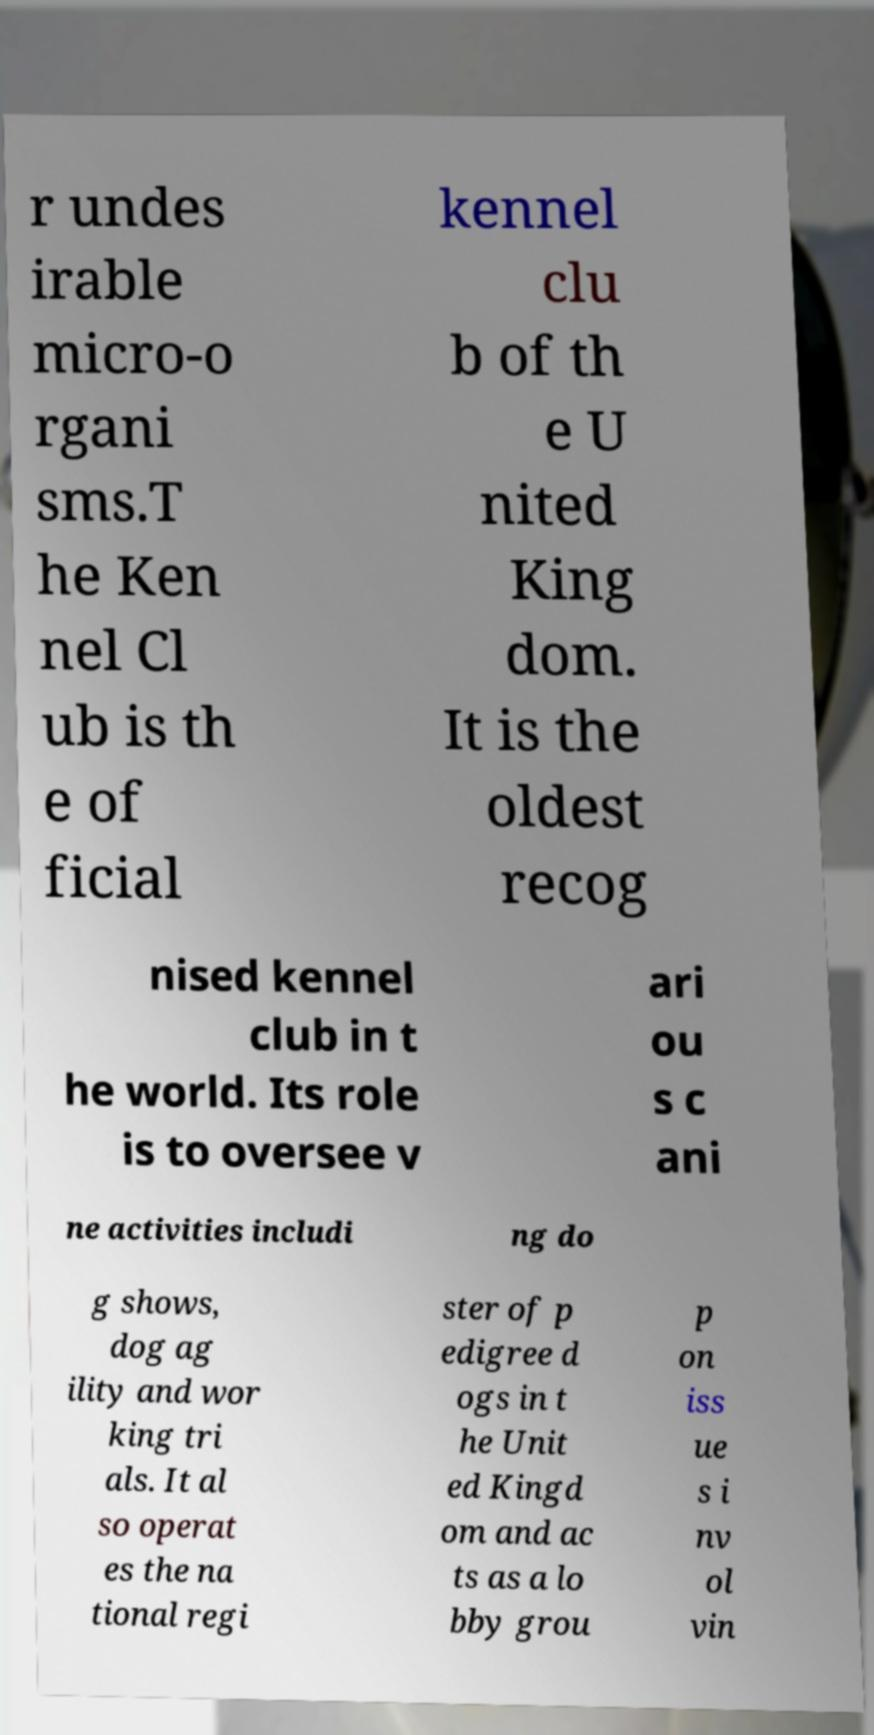Could you assist in decoding the text presented in this image and type it out clearly? r undes irable micro-o rgani sms.T he Ken nel Cl ub is th e of ficial kennel clu b of th e U nited King dom. It is the oldest recog nised kennel club in t he world. Its role is to oversee v ari ou s c ani ne activities includi ng do g shows, dog ag ility and wor king tri als. It al so operat es the na tional regi ster of p edigree d ogs in t he Unit ed Kingd om and ac ts as a lo bby grou p on iss ue s i nv ol vin 